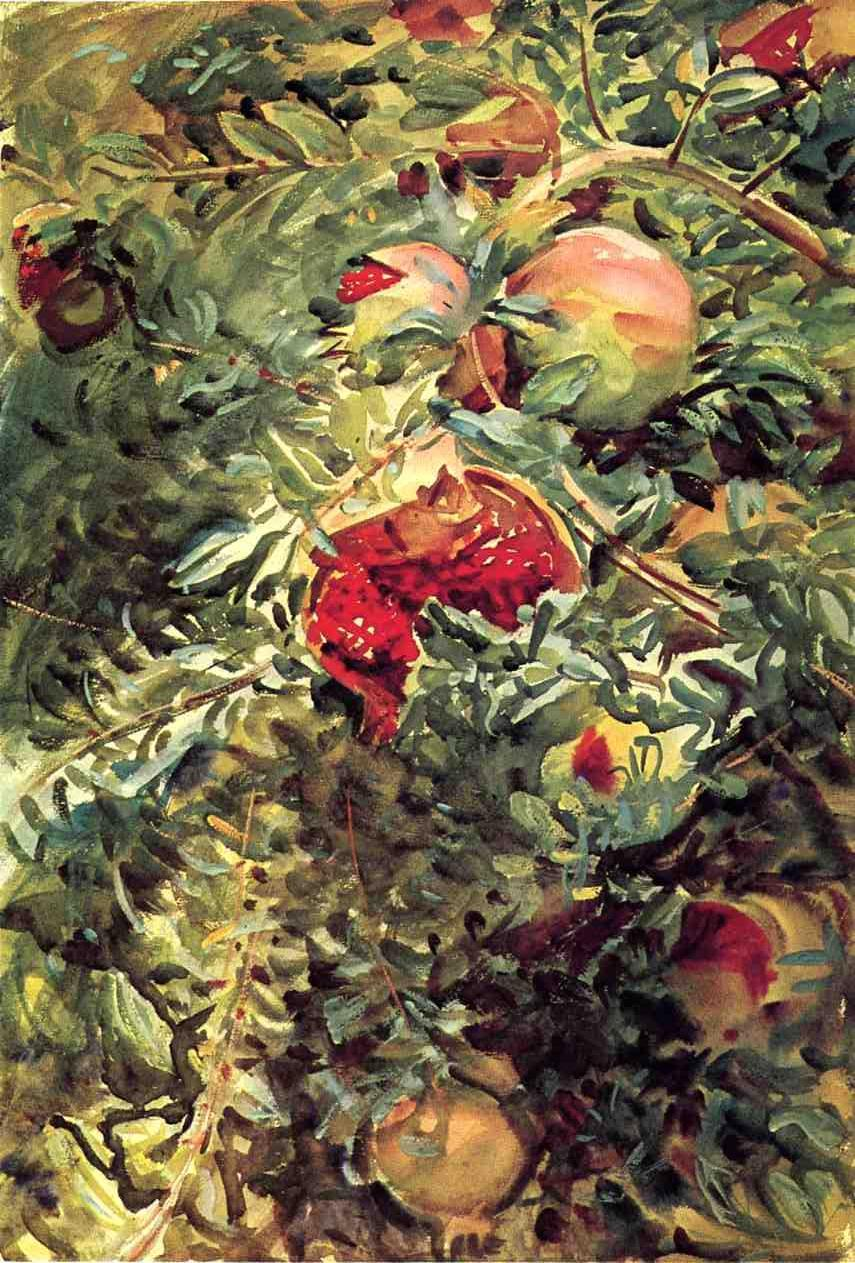What elements in this painting exemplify the impressionistic style? The painting exhibits classic impressionistic elements through its loose and visible brushstrokes that blend colors and shapes right on the canvas. The emphasis on light and color over detail, which allows for a greater emotional impression on the viewer rather than a clear, realistic depiction, is another hallmark of this style evident in this artwork. 